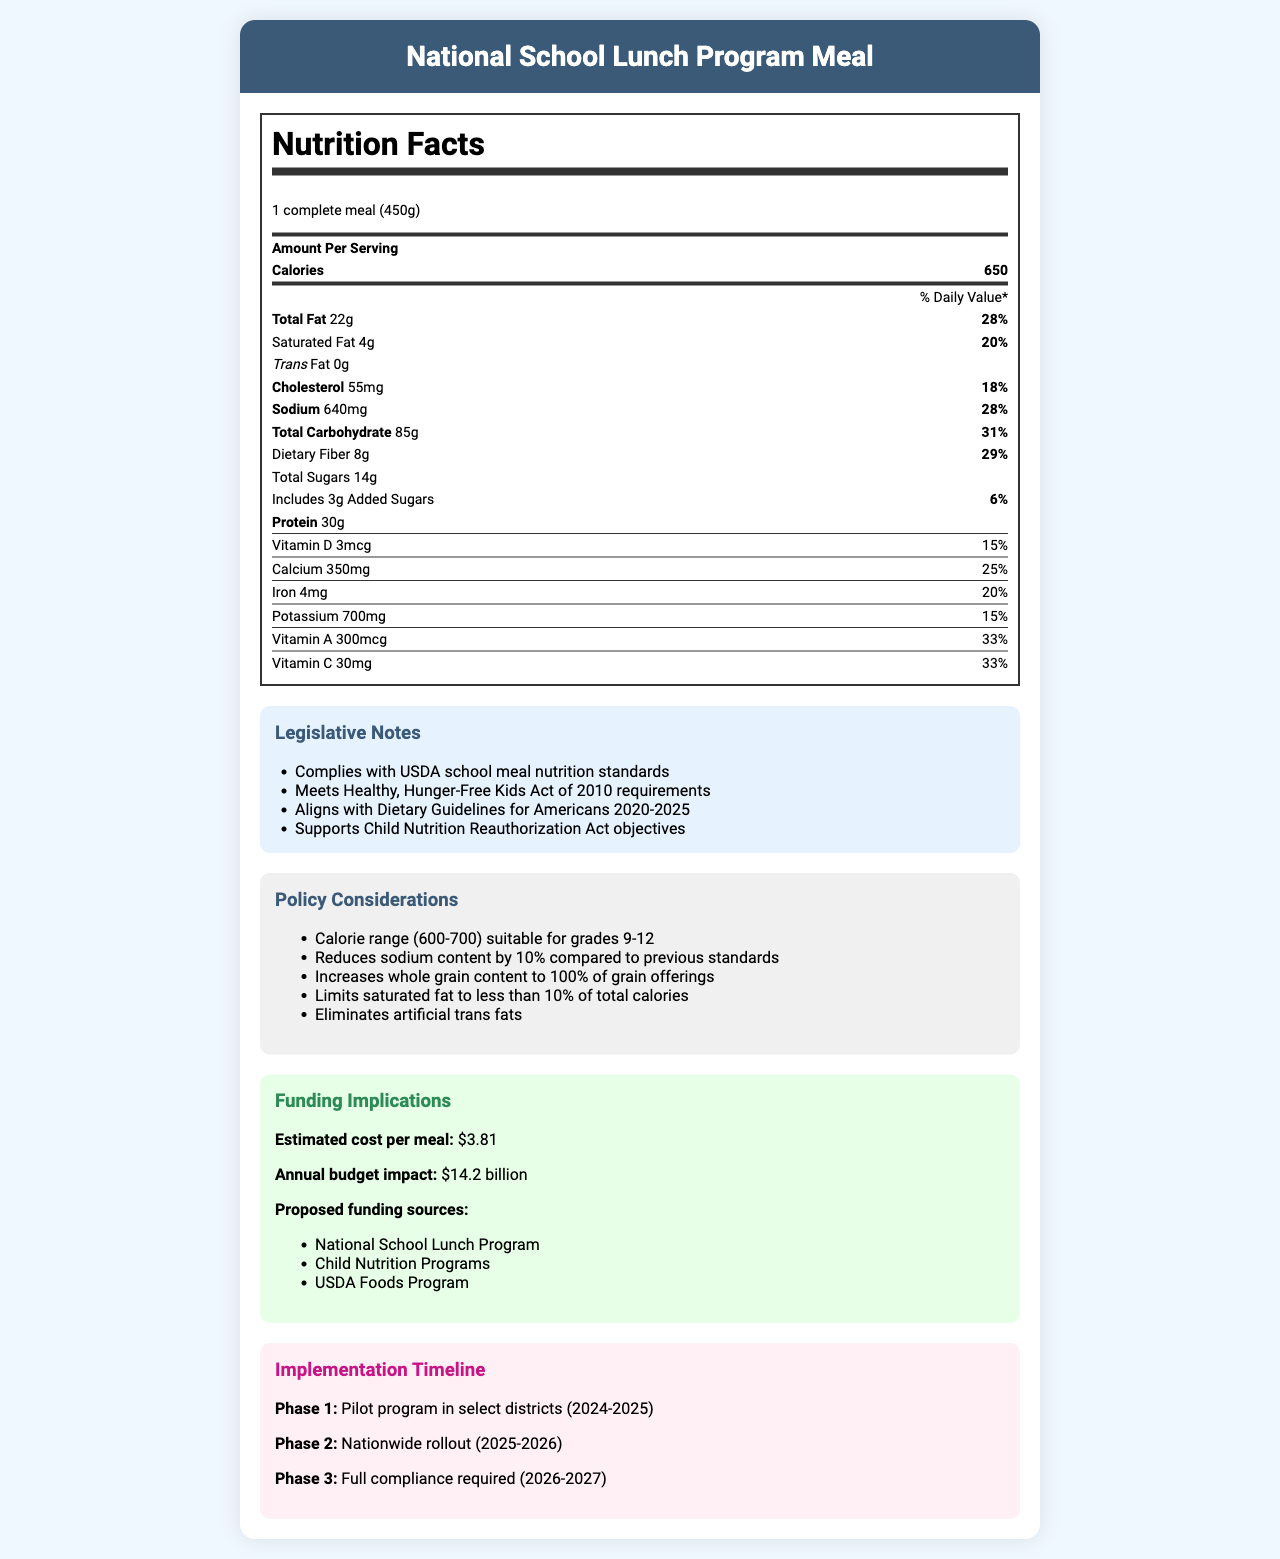who is the product intended for? The product is specifically named "National School Lunch Program Meal," indicating it is intended for students participating in the school lunch program.
Answer: National School Lunch Program what is the serving size of the meal? The serving size is listed as "1 complete meal (450g)" directly below the product's name.
Answer: 1 complete meal (450g) how many calories are in one serving? The Nutrition Facts label lists the calories per serving as "650" near the top of the label.
Answer: 650 calories what is the total fat content, and what percentage of the daily value does it represent? The total fat content is 22 grams, and it represents 28% of the daily value, as indicated in the Nutrition Facts table.
Answer: 22g, 28% how much dietary fiber does the meal contain, and what is its daily value percentage? The dietary fiber content is 8 grams, and it contributes to 29% of the daily value, as shown in the nutritional breakdown.
Answer: 8g, 29% what amount and percentage of daily value of added sugars are present in the meal? The meal contains 3 grams of added sugars, which is 6% of the daily value.
Answer: 3g, 6% does the document comply with the USDA school meal nutrition standards? One of the legislative notes states "Complies with USDA school meal nutrition standards."
Answer: Yes when will the nationwide rollout for the meal occur? The implementation timeline specifies "Phase 2: Nationwide rollout (2025-2026)."
Answer: 2025-2026 how much does each meal cost, and what is the annual budget impact? The estimated cost per meal is $3.81, and the annual budget impact is $14.2 billion, as shown in the funding implications section.
Answer: $3.81, $14.2 billion how does the meal support the Child Nutrition Reauthorization Act objectives? A. By increasing whole grain content B. By eliminating artificial trans fats C. By reducing sodium content D. All of the above The policy considerations note that the meal "increases whole grain content to 100% of grain offerings," "eliminates artificial trans fats," and "reduces sodium content by 10%."
Answer: D. All of the above what is the cholesterol content in the meal? A. 18mg B. 55mg C. 18% The cholesterol content is listed as "55mg" with a daily value percentage of 18%.
Answer: B. 55mg does the meal include any artificial trans fats? The policy considerations state that it "eliminates artificial trans fats."
Answer: No summarize the main purpose and content of the document. It offers a comprehensive overview of the nutritional content, cost, funding sources, and phased implementation of the meal designed for the National School Lunch Program, focusing on meeting legislative and nutritional standards.
Answer: The document provides detailed nutritional information about a National School Lunch Program meal, highlighting compliance with various nutritional standards and policies. It includes legislative notes, nutritional breakdown, policy considerations, funding implications, and an implementation timeline. how does the document ensure lower sodium content compared to previous standards? The policy considerations explicitly mention "reduces sodium content by 10% compared to previous standards."
Answer: It reduces sodium content by 10% compared to previous standards. which districts will participate in the pilot program? The document only states "Pilot program in select districts (2024-2025)" but does not specify which districts will participate.
Answer: Not enough information 